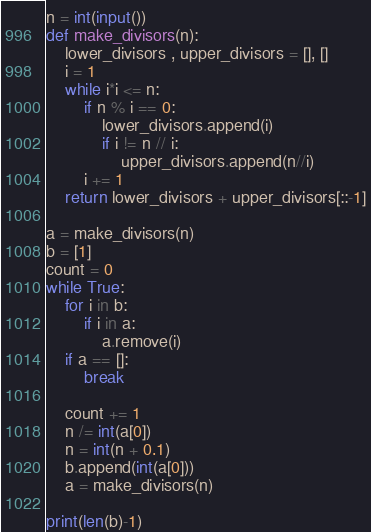<code> <loc_0><loc_0><loc_500><loc_500><_Python_>n = int(input())
def make_divisors(n):
    lower_divisors , upper_divisors = [], []
    i = 1
    while i*i <= n:
        if n % i == 0:
            lower_divisors.append(i)
            if i != n // i:
                upper_divisors.append(n//i)
        i += 1
    return lower_divisors + upper_divisors[::-1]

a = make_divisors(n)
b = [1]
count = 0
while True:
    for i in b:
        if i in a:
            a.remove(i)
    if a == []:
        break

    count += 1
    n /= int(a[0])
    n = int(n + 0.1)
    b.append(int(a[0]))
    a = make_divisors(n)
    
print(len(b)-1)</code> 